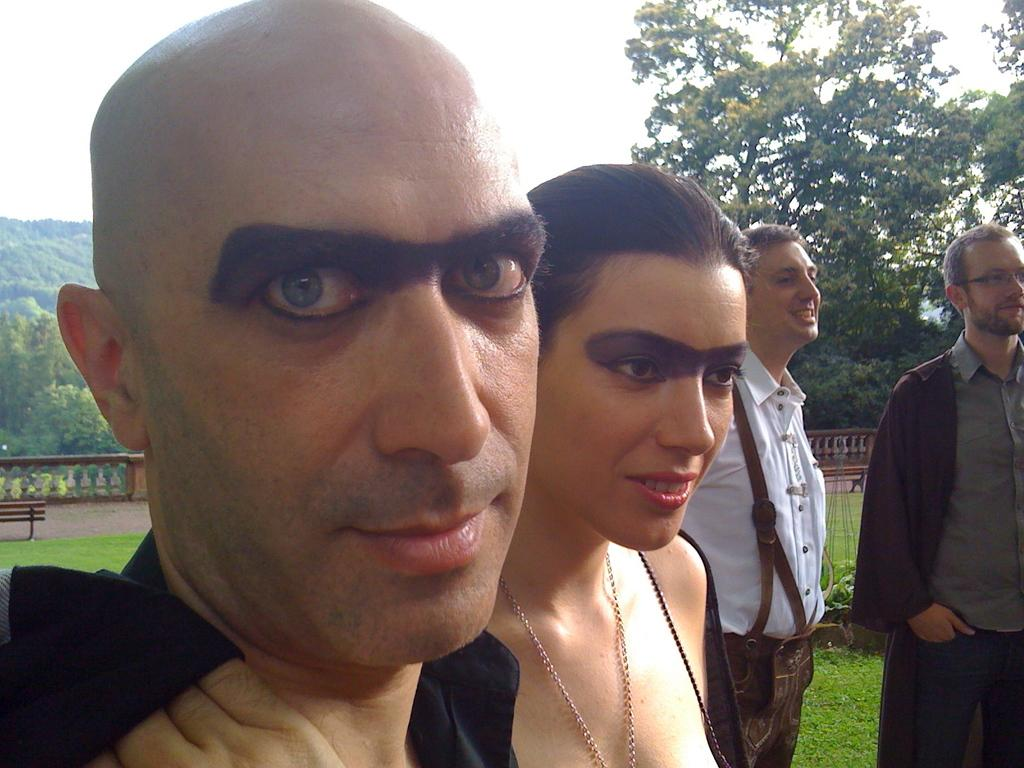How many persons can be seen in the image? There are persons standing in the image. What can be seen in the background of the image? There is a bench, grass, a railing, green trees, and the sky visible in the background of the image. What is the ground made of in the image? The ground is visible in the image, but the material is not specified. Can you describe the vegetation in the background of the image? There are green trees in the background of the image. What type of calculator is being used by the person in the image? There is no calculator present in the image. What color is the coat worn by the person in the image? There is no coat visible in the image. 